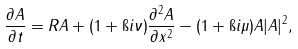<formula> <loc_0><loc_0><loc_500><loc_500>\frac { \partial A } { \partial t } = R A + ( 1 + \i i \nu ) \frac { \partial ^ { 2 } A } { \partial x ^ { 2 } } - ( 1 + \i i \mu ) A | A | ^ { 2 } ,</formula> 